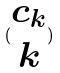<formula> <loc_0><loc_0><loc_500><loc_500>( \begin{matrix} c _ { k } \\ k \end{matrix} )</formula> 